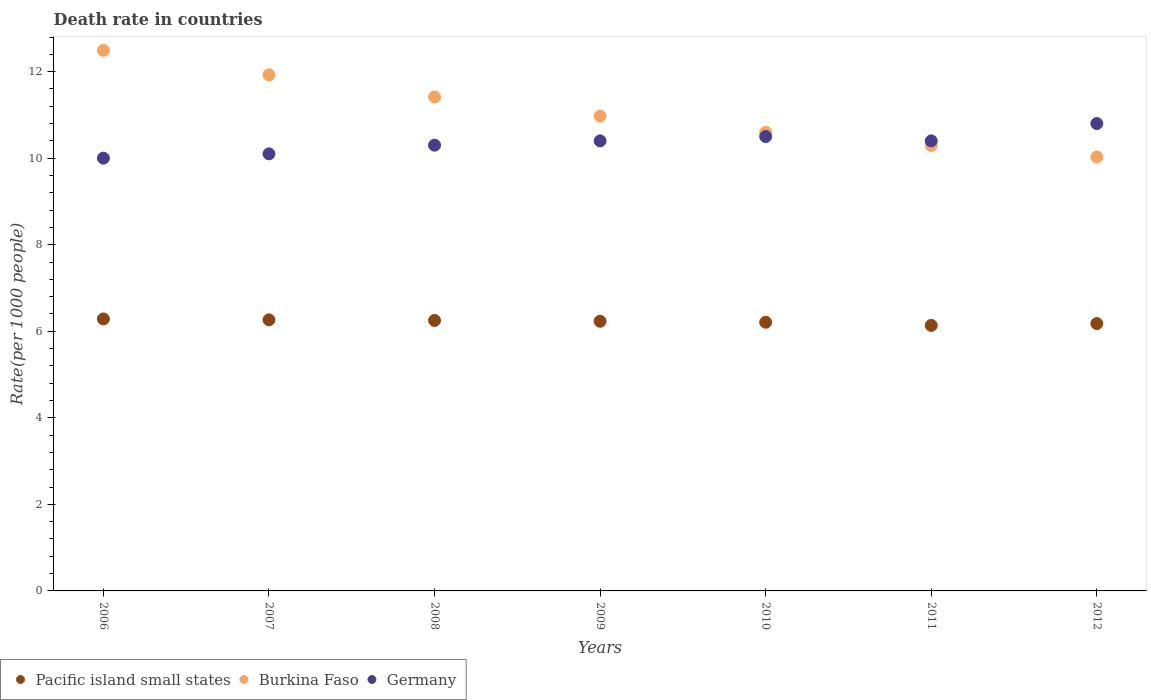What is the death rate in Pacific island small states in 2011?
Make the answer very short. 6.14. Across all years, what is the maximum death rate in Burkina Faso?
Offer a very short reply. 12.49. Across all years, what is the minimum death rate in Burkina Faso?
Give a very brief answer. 10.03. In which year was the death rate in Burkina Faso minimum?
Offer a very short reply. 2012. What is the total death rate in Germany in the graph?
Ensure brevity in your answer.  72.5. What is the difference between the death rate in Germany in 2006 and that in 2011?
Your answer should be very brief. -0.4. What is the difference between the death rate in Burkina Faso in 2006 and the death rate in Germany in 2007?
Provide a short and direct response. 2.39. What is the average death rate in Germany per year?
Ensure brevity in your answer.  10.36. In the year 2008, what is the difference between the death rate in Germany and death rate in Pacific island small states?
Provide a short and direct response. 4.05. What is the ratio of the death rate in Pacific island small states in 2010 to that in 2012?
Offer a very short reply. 1. What is the difference between the highest and the second highest death rate in Burkina Faso?
Provide a short and direct response. 0.57. What is the difference between the highest and the lowest death rate in Burkina Faso?
Your answer should be very brief. 2.46. Is the sum of the death rate in Pacific island small states in 2008 and 2009 greater than the maximum death rate in Burkina Faso across all years?
Keep it short and to the point. No. Is it the case that in every year, the sum of the death rate in Pacific island small states and death rate in Burkina Faso  is greater than the death rate in Germany?
Your answer should be very brief. Yes. Is the death rate in Burkina Faso strictly less than the death rate in Germany over the years?
Make the answer very short. No. Are the values on the major ticks of Y-axis written in scientific E-notation?
Give a very brief answer. No. Does the graph contain any zero values?
Give a very brief answer. No. How many legend labels are there?
Keep it short and to the point. 3. How are the legend labels stacked?
Your answer should be compact. Horizontal. What is the title of the graph?
Make the answer very short. Death rate in countries. Does "Saudi Arabia" appear as one of the legend labels in the graph?
Your answer should be very brief. No. What is the label or title of the Y-axis?
Offer a terse response. Rate(per 1000 people). What is the Rate(per 1000 people) in Pacific island small states in 2006?
Provide a short and direct response. 6.28. What is the Rate(per 1000 people) of Burkina Faso in 2006?
Your answer should be compact. 12.49. What is the Rate(per 1000 people) of Germany in 2006?
Offer a very short reply. 10. What is the Rate(per 1000 people) of Pacific island small states in 2007?
Keep it short and to the point. 6.26. What is the Rate(per 1000 people) in Burkina Faso in 2007?
Offer a very short reply. 11.93. What is the Rate(per 1000 people) of Germany in 2007?
Offer a very short reply. 10.1. What is the Rate(per 1000 people) of Pacific island small states in 2008?
Your answer should be very brief. 6.25. What is the Rate(per 1000 people) of Burkina Faso in 2008?
Keep it short and to the point. 11.41. What is the Rate(per 1000 people) in Germany in 2008?
Ensure brevity in your answer.  10.3. What is the Rate(per 1000 people) of Pacific island small states in 2009?
Your answer should be very brief. 6.23. What is the Rate(per 1000 people) in Burkina Faso in 2009?
Keep it short and to the point. 10.97. What is the Rate(per 1000 people) of Germany in 2009?
Provide a short and direct response. 10.4. What is the Rate(per 1000 people) in Pacific island small states in 2010?
Your answer should be compact. 6.21. What is the Rate(per 1000 people) in Germany in 2010?
Your answer should be compact. 10.5. What is the Rate(per 1000 people) of Pacific island small states in 2011?
Offer a terse response. 6.14. What is the Rate(per 1000 people) in Burkina Faso in 2011?
Your answer should be very brief. 10.29. What is the Rate(per 1000 people) in Pacific island small states in 2012?
Your answer should be very brief. 6.18. What is the Rate(per 1000 people) of Burkina Faso in 2012?
Your answer should be very brief. 10.03. What is the Rate(per 1000 people) of Germany in 2012?
Ensure brevity in your answer.  10.8. Across all years, what is the maximum Rate(per 1000 people) in Pacific island small states?
Give a very brief answer. 6.28. Across all years, what is the maximum Rate(per 1000 people) in Burkina Faso?
Your answer should be very brief. 12.49. Across all years, what is the maximum Rate(per 1000 people) of Germany?
Your answer should be very brief. 10.8. Across all years, what is the minimum Rate(per 1000 people) of Pacific island small states?
Make the answer very short. 6.14. Across all years, what is the minimum Rate(per 1000 people) in Burkina Faso?
Give a very brief answer. 10.03. What is the total Rate(per 1000 people) in Pacific island small states in the graph?
Offer a very short reply. 43.55. What is the total Rate(per 1000 people) of Burkina Faso in the graph?
Ensure brevity in your answer.  77.72. What is the total Rate(per 1000 people) of Germany in the graph?
Keep it short and to the point. 72.5. What is the difference between the Rate(per 1000 people) of Pacific island small states in 2006 and that in 2007?
Provide a short and direct response. 0.02. What is the difference between the Rate(per 1000 people) in Burkina Faso in 2006 and that in 2007?
Offer a very short reply. 0.57. What is the difference between the Rate(per 1000 people) of Germany in 2006 and that in 2007?
Offer a very short reply. -0.1. What is the difference between the Rate(per 1000 people) of Pacific island small states in 2006 and that in 2008?
Ensure brevity in your answer.  0.03. What is the difference between the Rate(per 1000 people) in Burkina Faso in 2006 and that in 2008?
Offer a terse response. 1.08. What is the difference between the Rate(per 1000 people) of Pacific island small states in 2006 and that in 2009?
Your answer should be very brief. 0.05. What is the difference between the Rate(per 1000 people) of Burkina Faso in 2006 and that in 2009?
Offer a terse response. 1.52. What is the difference between the Rate(per 1000 people) in Pacific island small states in 2006 and that in 2010?
Offer a terse response. 0.08. What is the difference between the Rate(per 1000 people) in Burkina Faso in 2006 and that in 2010?
Offer a terse response. 1.89. What is the difference between the Rate(per 1000 people) of Pacific island small states in 2006 and that in 2011?
Your answer should be very brief. 0.15. What is the difference between the Rate(per 1000 people) of Burkina Faso in 2006 and that in 2011?
Give a very brief answer. 2.2. What is the difference between the Rate(per 1000 people) in Germany in 2006 and that in 2011?
Provide a short and direct response. -0.4. What is the difference between the Rate(per 1000 people) of Pacific island small states in 2006 and that in 2012?
Ensure brevity in your answer.  0.11. What is the difference between the Rate(per 1000 people) of Burkina Faso in 2006 and that in 2012?
Make the answer very short. 2.46. What is the difference between the Rate(per 1000 people) in Pacific island small states in 2007 and that in 2008?
Provide a succinct answer. 0.01. What is the difference between the Rate(per 1000 people) of Burkina Faso in 2007 and that in 2008?
Your answer should be compact. 0.51. What is the difference between the Rate(per 1000 people) in Pacific island small states in 2007 and that in 2009?
Your answer should be very brief. 0.03. What is the difference between the Rate(per 1000 people) of Burkina Faso in 2007 and that in 2009?
Offer a very short reply. 0.95. What is the difference between the Rate(per 1000 people) in Germany in 2007 and that in 2009?
Give a very brief answer. -0.3. What is the difference between the Rate(per 1000 people) of Pacific island small states in 2007 and that in 2010?
Make the answer very short. 0.06. What is the difference between the Rate(per 1000 people) in Burkina Faso in 2007 and that in 2010?
Offer a terse response. 1.33. What is the difference between the Rate(per 1000 people) of Germany in 2007 and that in 2010?
Offer a terse response. -0.4. What is the difference between the Rate(per 1000 people) in Pacific island small states in 2007 and that in 2011?
Ensure brevity in your answer.  0.13. What is the difference between the Rate(per 1000 people) in Burkina Faso in 2007 and that in 2011?
Your answer should be compact. 1.63. What is the difference between the Rate(per 1000 people) in Pacific island small states in 2007 and that in 2012?
Offer a terse response. 0.09. What is the difference between the Rate(per 1000 people) in Burkina Faso in 2007 and that in 2012?
Give a very brief answer. 1.9. What is the difference between the Rate(per 1000 people) of Pacific island small states in 2008 and that in 2009?
Make the answer very short. 0.02. What is the difference between the Rate(per 1000 people) in Burkina Faso in 2008 and that in 2009?
Offer a very short reply. 0.44. What is the difference between the Rate(per 1000 people) of Pacific island small states in 2008 and that in 2010?
Make the answer very short. 0.04. What is the difference between the Rate(per 1000 people) of Burkina Faso in 2008 and that in 2010?
Keep it short and to the point. 0.81. What is the difference between the Rate(per 1000 people) of Pacific island small states in 2008 and that in 2011?
Your answer should be very brief. 0.11. What is the difference between the Rate(per 1000 people) in Burkina Faso in 2008 and that in 2011?
Provide a succinct answer. 1.12. What is the difference between the Rate(per 1000 people) in Germany in 2008 and that in 2011?
Your response must be concise. -0.1. What is the difference between the Rate(per 1000 people) in Pacific island small states in 2008 and that in 2012?
Provide a short and direct response. 0.07. What is the difference between the Rate(per 1000 people) of Burkina Faso in 2008 and that in 2012?
Offer a very short reply. 1.39. What is the difference between the Rate(per 1000 people) of Germany in 2008 and that in 2012?
Your answer should be compact. -0.5. What is the difference between the Rate(per 1000 people) in Pacific island small states in 2009 and that in 2010?
Ensure brevity in your answer.  0.02. What is the difference between the Rate(per 1000 people) in Burkina Faso in 2009 and that in 2010?
Your answer should be compact. 0.37. What is the difference between the Rate(per 1000 people) in Pacific island small states in 2009 and that in 2011?
Make the answer very short. 0.1. What is the difference between the Rate(per 1000 people) of Burkina Faso in 2009 and that in 2011?
Your response must be concise. 0.68. What is the difference between the Rate(per 1000 people) of Pacific island small states in 2009 and that in 2012?
Your answer should be very brief. 0.05. What is the difference between the Rate(per 1000 people) in Burkina Faso in 2009 and that in 2012?
Offer a very short reply. 0.94. What is the difference between the Rate(per 1000 people) of Germany in 2009 and that in 2012?
Provide a succinct answer. -0.4. What is the difference between the Rate(per 1000 people) of Pacific island small states in 2010 and that in 2011?
Your answer should be very brief. 0.07. What is the difference between the Rate(per 1000 people) in Burkina Faso in 2010 and that in 2011?
Your answer should be compact. 0.31. What is the difference between the Rate(per 1000 people) in Germany in 2010 and that in 2011?
Keep it short and to the point. 0.1. What is the difference between the Rate(per 1000 people) of Pacific island small states in 2010 and that in 2012?
Provide a short and direct response. 0.03. What is the difference between the Rate(per 1000 people) of Burkina Faso in 2010 and that in 2012?
Keep it short and to the point. 0.57. What is the difference between the Rate(per 1000 people) of Germany in 2010 and that in 2012?
Keep it short and to the point. -0.3. What is the difference between the Rate(per 1000 people) in Pacific island small states in 2011 and that in 2012?
Your answer should be very brief. -0.04. What is the difference between the Rate(per 1000 people) in Burkina Faso in 2011 and that in 2012?
Keep it short and to the point. 0.26. What is the difference between the Rate(per 1000 people) in Pacific island small states in 2006 and the Rate(per 1000 people) in Burkina Faso in 2007?
Offer a terse response. -5.64. What is the difference between the Rate(per 1000 people) of Pacific island small states in 2006 and the Rate(per 1000 people) of Germany in 2007?
Your answer should be very brief. -3.82. What is the difference between the Rate(per 1000 people) of Burkina Faso in 2006 and the Rate(per 1000 people) of Germany in 2007?
Make the answer very short. 2.39. What is the difference between the Rate(per 1000 people) of Pacific island small states in 2006 and the Rate(per 1000 people) of Burkina Faso in 2008?
Your answer should be compact. -5.13. What is the difference between the Rate(per 1000 people) in Pacific island small states in 2006 and the Rate(per 1000 people) in Germany in 2008?
Keep it short and to the point. -4.02. What is the difference between the Rate(per 1000 people) in Burkina Faso in 2006 and the Rate(per 1000 people) in Germany in 2008?
Your answer should be very brief. 2.19. What is the difference between the Rate(per 1000 people) in Pacific island small states in 2006 and the Rate(per 1000 people) in Burkina Faso in 2009?
Keep it short and to the point. -4.69. What is the difference between the Rate(per 1000 people) in Pacific island small states in 2006 and the Rate(per 1000 people) in Germany in 2009?
Provide a succinct answer. -4.12. What is the difference between the Rate(per 1000 people) of Burkina Faso in 2006 and the Rate(per 1000 people) of Germany in 2009?
Keep it short and to the point. 2.09. What is the difference between the Rate(per 1000 people) of Pacific island small states in 2006 and the Rate(per 1000 people) of Burkina Faso in 2010?
Make the answer very short. -4.32. What is the difference between the Rate(per 1000 people) in Pacific island small states in 2006 and the Rate(per 1000 people) in Germany in 2010?
Give a very brief answer. -4.22. What is the difference between the Rate(per 1000 people) of Burkina Faso in 2006 and the Rate(per 1000 people) of Germany in 2010?
Make the answer very short. 1.99. What is the difference between the Rate(per 1000 people) in Pacific island small states in 2006 and the Rate(per 1000 people) in Burkina Faso in 2011?
Give a very brief answer. -4.01. What is the difference between the Rate(per 1000 people) of Pacific island small states in 2006 and the Rate(per 1000 people) of Germany in 2011?
Offer a very short reply. -4.12. What is the difference between the Rate(per 1000 people) in Burkina Faso in 2006 and the Rate(per 1000 people) in Germany in 2011?
Offer a very short reply. 2.09. What is the difference between the Rate(per 1000 people) in Pacific island small states in 2006 and the Rate(per 1000 people) in Burkina Faso in 2012?
Your response must be concise. -3.74. What is the difference between the Rate(per 1000 people) of Pacific island small states in 2006 and the Rate(per 1000 people) of Germany in 2012?
Provide a succinct answer. -4.52. What is the difference between the Rate(per 1000 people) of Burkina Faso in 2006 and the Rate(per 1000 people) of Germany in 2012?
Give a very brief answer. 1.69. What is the difference between the Rate(per 1000 people) of Pacific island small states in 2007 and the Rate(per 1000 people) of Burkina Faso in 2008?
Give a very brief answer. -5.15. What is the difference between the Rate(per 1000 people) in Pacific island small states in 2007 and the Rate(per 1000 people) in Germany in 2008?
Keep it short and to the point. -4.04. What is the difference between the Rate(per 1000 people) of Burkina Faso in 2007 and the Rate(per 1000 people) of Germany in 2008?
Ensure brevity in your answer.  1.63. What is the difference between the Rate(per 1000 people) of Pacific island small states in 2007 and the Rate(per 1000 people) of Burkina Faso in 2009?
Your response must be concise. -4.71. What is the difference between the Rate(per 1000 people) in Pacific island small states in 2007 and the Rate(per 1000 people) in Germany in 2009?
Your response must be concise. -4.14. What is the difference between the Rate(per 1000 people) of Burkina Faso in 2007 and the Rate(per 1000 people) of Germany in 2009?
Provide a succinct answer. 1.53. What is the difference between the Rate(per 1000 people) in Pacific island small states in 2007 and the Rate(per 1000 people) in Burkina Faso in 2010?
Offer a terse response. -4.34. What is the difference between the Rate(per 1000 people) in Pacific island small states in 2007 and the Rate(per 1000 people) in Germany in 2010?
Offer a terse response. -4.24. What is the difference between the Rate(per 1000 people) in Burkina Faso in 2007 and the Rate(per 1000 people) in Germany in 2010?
Make the answer very short. 1.43. What is the difference between the Rate(per 1000 people) of Pacific island small states in 2007 and the Rate(per 1000 people) of Burkina Faso in 2011?
Ensure brevity in your answer.  -4.03. What is the difference between the Rate(per 1000 people) in Pacific island small states in 2007 and the Rate(per 1000 people) in Germany in 2011?
Give a very brief answer. -4.14. What is the difference between the Rate(per 1000 people) of Burkina Faso in 2007 and the Rate(per 1000 people) of Germany in 2011?
Your answer should be very brief. 1.53. What is the difference between the Rate(per 1000 people) in Pacific island small states in 2007 and the Rate(per 1000 people) in Burkina Faso in 2012?
Make the answer very short. -3.76. What is the difference between the Rate(per 1000 people) of Pacific island small states in 2007 and the Rate(per 1000 people) of Germany in 2012?
Ensure brevity in your answer.  -4.54. What is the difference between the Rate(per 1000 people) of Burkina Faso in 2007 and the Rate(per 1000 people) of Germany in 2012?
Keep it short and to the point. 1.13. What is the difference between the Rate(per 1000 people) of Pacific island small states in 2008 and the Rate(per 1000 people) of Burkina Faso in 2009?
Provide a short and direct response. -4.72. What is the difference between the Rate(per 1000 people) of Pacific island small states in 2008 and the Rate(per 1000 people) of Germany in 2009?
Provide a succinct answer. -4.15. What is the difference between the Rate(per 1000 people) in Pacific island small states in 2008 and the Rate(per 1000 people) in Burkina Faso in 2010?
Keep it short and to the point. -4.35. What is the difference between the Rate(per 1000 people) in Pacific island small states in 2008 and the Rate(per 1000 people) in Germany in 2010?
Offer a very short reply. -4.25. What is the difference between the Rate(per 1000 people) of Burkina Faso in 2008 and the Rate(per 1000 people) of Germany in 2010?
Provide a succinct answer. 0.92. What is the difference between the Rate(per 1000 people) in Pacific island small states in 2008 and the Rate(per 1000 people) in Burkina Faso in 2011?
Keep it short and to the point. -4.04. What is the difference between the Rate(per 1000 people) in Pacific island small states in 2008 and the Rate(per 1000 people) in Germany in 2011?
Your answer should be compact. -4.15. What is the difference between the Rate(per 1000 people) in Burkina Faso in 2008 and the Rate(per 1000 people) in Germany in 2011?
Your response must be concise. 1.01. What is the difference between the Rate(per 1000 people) in Pacific island small states in 2008 and the Rate(per 1000 people) in Burkina Faso in 2012?
Your response must be concise. -3.78. What is the difference between the Rate(per 1000 people) in Pacific island small states in 2008 and the Rate(per 1000 people) in Germany in 2012?
Give a very brief answer. -4.55. What is the difference between the Rate(per 1000 people) of Burkina Faso in 2008 and the Rate(per 1000 people) of Germany in 2012?
Ensure brevity in your answer.  0.61. What is the difference between the Rate(per 1000 people) in Pacific island small states in 2009 and the Rate(per 1000 people) in Burkina Faso in 2010?
Make the answer very short. -4.37. What is the difference between the Rate(per 1000 people) in Pacific island small states in 2009 and the Rate(per 1000 people) in Germany in 2010?
Offer a very short reply. -4.27. What is the difference between the Rate(per 1000 people) of Burkina Faso in 2009 and the Rate(per 1000 people) of Germany in 2010?
Ensure brevity in your answer.  0.47. What is the difference between the Rate(per 1000 people) of Pacific island small states in 2009 and the Rate(per 1000 people) of Burkina Faso in 2011?
Ensure brevity in your answer.  -4.06. What is the difference between the Rate(per 1000 people) of Pacific island small states in 2009 and the Rate(per 1000 people) of Germany in 2011?
Give a very brief answer. -4.17. What is the difference between the Rate(per 1000 people) in Burkina Faso in 2009 and the Rate(per 1000 people) in Germany in 2011?
Give a very brief answer. 0.57. What is the difference between the Rate(per 1000 people) in Pacific island small states in 2009 and the Rate(per 1000 people) in Burkina Faso in 2012?
Provide a short and direct response. -3.8. What is the difference between the Rate(per 1000 people) of Pacific island small states in 2009 and the Rate(per 1000 people) of Germany in 2012?
Offer a terse response. -4.57. What is the difference between the Rate(per 1000 people) in Burkina Faso in 2009 and the Rate(per 1000 people) in Germany in 2012?
Your answer should be very brief. 0.17. What is the difference between the Rate(per 1000 people) of Pacific island small states in 2010 and the Rate(per 1000 people) of Burkina Faso in 2011?
Your answer should be very brief. -4.08. What is the difference between the Rate(per 1000 people) of Pacific island small states in 2010 and the Rate(per 1000 people) of Germany in 2011?
Give a very brief answer. -4.19. What is the difference between the Rate(per 1000 people) in Burkina Faso in 2010 and the Rate(per 1000 people) in Germany in 2011?
Your answer should be very brief. 0.2. What is the difference between the Rate(per 1000 people) in Pacific island small states in 2010 and the Rate(per 1000 people) in Burkina Faso in 2012?
Provide a short and direct response. -3.82. What is the difference between the Rate(per 1000 people) in Pacific island small states in 2010 and the Rate(per 1000 people) in Germany in 2012?
Offer a very short reply. -4.59. What is the difference between the Rate(per 1000 people) of Burkina Faso in 2010 and the Rate(per 1000 people) of Germany in 2012?
Provide a short and direct response. -0.2. What is the difference between the Rate(per 1000 people) of Pacific island small states in 2011 and the Rate(per 1000 people) of Burkina Faso in 2012?
Your answer should be compact. -3.89. What is the difference between the Rate(per 1000 people) of Pacific island small states in 2011 and the Rate(per 1000 people) of Germany in 2012?
Your response must be concise. -4.66. What is the difference between the Rate(per 1000 people) in Burkina Faso in 2011 and the Rate(per 1000 people) in Germany in 2012?
Ensure brevity in your answer.  -0.51. What is the average Rate(per 1000 people) in Pacific island small states per year?
Provide a succinct answer. 6.22. What is the average Rate(per 1000 people) in Burkina Faso per year?
Your answer should be compact. 11.1. What is the average Rate(per 1000 people) of Germany per year?
Keep it short and to the point. 10.36. In the year 2006, what is the difference between the Rate(per 1000 people) in Pacific island small states and Rate(per 1000 people) in Burkina Faso?
Your answer should be compact. -6.21. In the year 2006, what is the difference between the Rate(per 1000 people) of Pacific island small states and Rate(per 1000 people) of Germany?
Your answer should be very brief. -3.72. In the year 2006, what is the difference between the Rate(per 1000 people) in Burkina Faso and Rate(per 1000 people) in Germany?
Provide a succinct answer. 2.49. In the year 2007, what is the difference between the Rate(per 1000 people) of Pacific island small states and Rate(per 1000 people) of Burkina Faso?
Your answer should be compact. -5.66. In the year 2007, what is the difference between the Rate(per 1000 people) of Pacific island small states and Rate(per 1000 people) of Germany?
Ensure brevity in your answer.  -3.84. In the year 2007, what is the difference between the Rate(per 1000 people) in Burkina Faso and Rate(per 1000 people) in Germany?
Keep it short and to the point. 1.83. In the year 2008, what is the difference between the Rate(per 1000 people) of Pacific island small states and Rate(per 1000 people) of Burkina Faso?
Offer a terse response. -5.17. In the year 2008, what is the difference between the Rate(per 1000 people) of Pacific island small states and Rate(per 1000 people) of Germany?
Give a very brief answer. -4.05. In the year 2008, what is the difference between the Rate(per 1000 people) in Burkina Faso and Rate(per 1000 people) in Germany?
Give a very brief answer. 1.11. In the year 2009, what is the difference between the Rate(per 1000 people) of Pacific island small states and Rate(per 1000 people) of Burkina Faso?
Offer a terse response. -4.74. In the year 2009, what is the difference between the Rate(per 1000 people) in Pacific island small states and Rate(per 1000 people) in Germany?
Your answer should be compact. -4.17. In the year 2009, what is the difference between the Rate(per 1000 people) in Burkina Faso and Rate(per 1000 people) in Germany?
Provide a short and direct response. 0.57. In the year 2010, what is the difference between the Rate(per 1000 people) in Pacific island small states and Rate(per 1000 people) in Burkina Faso?
Make the answer very short. -4.39. In the year 2010, what is the difference between the Rate(per 1000 people) of Pacific island small states and Rate(per 1000 people) of Germany?
Your answer should be compact. -4.29. In the year 2010, what is the difference between the Rate(per 1000 people) in Burkina Faso and Rate(per 1000 people) in Germany?
Give a very brief answer. 0.1. In the year 2011, what is the difference between the Rate(per 1000 people) of Pacific island small states and Rate(per 1000 people) of Burkina Faso?
Give a very brief answer. -4.16. In the year 2011, what is the difference between the Rate(per 1000 people) in Pacific island small states and Rate(per 1000 people) in Germany?
Offer a very short reply. -4.26. In the year 2011, what is the difference between the Rate(per 1000 people) of Burkina Faso and Rate(per 1000 people) of Germany?
Offer a terse response. -0.11. In the year 2012, what is the difference between the Rate(per 1000 people) in Pacific island small states and Rate(per 1000 people) in Burkina Faso?
Your response must be concise. -3.85. In the year 2012, what is the difference between the Rate(per 1000 people) of Pacific island small states and Rate(per 1000 people) of Germany?
Make the answer very short. -4.62. In the year 2012, what is the difference between the Rate(per 1000 people) in Burkina Faso and Rate(per 1000 people) in Germany?
Your answer should be compact. -0.77. What is the ratio of the Rate(per 1000 people) of Pacific island small states in 2006 to that in 2007?
Your answer should be compact. 1. What is the ratio of the Rate(per 1000 people) of Burkina Faso in 2006 to that in 2007?
Your answer should be compact. 1.05. What is the ratio of the Rate(per 1000 people) of Pacific island small states in 2006 to that in 2008?
Your answer should be compact. 1.01. What is the ratio of the Rate(per 1000 people) in Burkina Faso in 2006 to that in 2008?
Give a very brief answer. 1.09. What is the ratio of the Rate(per 1000 people) of Germany in 2006 to that in 2008?
Offer a very short reply. 0.97. What is the ratio of the Rate(per 1000 people) of Pacific island small states in 2006 to that in 2009?
Your response must be concise. 1.01. What is the ratio of the Rate(per 1000 people) in Burkina Faso in 2006 to that in 2009?
Ensure brevity in your answer.  1.14. What is the ratio of the Rate(per 1000 people) of Germany in 2006 to that in 2009?
Keep it short and to the point. 0.96. What is the ratio of the Rate(per 1000 people) of Pacific island small states in 2006 to that in 2010?
Provide a succinct answer. 1.01. What is the ratio of the Rate(per 1000 people) of Burkina Faso in 2006 to that in 2010?
Make the answer very short. 1.18. What is the ratio of the Rate(per 1000 people) in Germany in 2006 to that in 2010?
Your response must be concise. 0.95. What is the ratio of the Rate(per 1000 people) of Pacific island small states in 2006 to that in 2011?
Give a very brief answer. 1.02. What is the ratio of the Rate(per 1000 people) of Burkina Faso in 2006 to that in 2011?
Make the answer very short. 1.21. What is the ratio of the Rate(per 1000 people) in Germany in 2006 to that in 2011?
Offer a terse response. 0.96. What is the ratio of the Rate(per 1000 people) in Pacific island small states in 2006 to that in 2012?
Your answer should be very brief. 1.02. What is the ratio of the Rate(per 1000 people) of Burkina Faso in 2006 to that in 2012?
Give a very brief answer. 1.25. What is the ratio of the Rate(per 1000 people) of Germany in 2006 to that in 2012?
Your answer should be compact. 0.93. What is the ratio of the Rate(per 1000 people) of Burkina Faso in 2007 to that in 2008?
Provide a succinct answer. 1.04. What is the ratio of the Rate(per 1000 people) of Germany in 2007 to that in 2008?
Give a very brief answer. 0.98. What is the ratio of the Rate(per 1000 people) in Burkina Faso in 2007 to that in 2009?
Your response must be concise. 1.09. What is the ratio of the Rate(per 1000 people) in Germany in 2007 to that in 2009?
Make the answer very short. 0.97. What is the ratio of the Rate(per 1000 people) in Pacific island small states in 2007 to that in 2010?
Make the answer very short. 1.01. What is the ratio of the Rate(per 1000 people) of Burkina Faso in 2007 to that in 2010?
Your answer should be compact. 1.13. What is the ratio of the Rate(per 1000 people) in Germany in 2007 to that in 2010?
Your response must be concise. 0.96. What is the ratio of the Rate(per 1000 people) of Pacific island small states in 2007 to that in 2011?
Your response must be concise. 1.02. What is the ratio of the Rate(per 1000 people) of Burkina Faso in 2007 to that in 2011?
Offer a very short reply. 1.16. What is the ratio of the Rate(per 1000 people) of Germany in 2007 to that in 2011?
Offer a terse response. 0.97. What is the ratio of the Rate(per 1000 people) in Pacific island small states in 2007 to that in 2012?
Give a very brief answer. 1.01. What is the ratio of the Rate(per 1000 people) in Burkina Faso in 2007 to that in 2012?
Ensure brevity in your answer.  1.19. What is the ratio of the Rate(per 1000 people) of Germany in 2007 to that in 2012?
Provide a succinct answer. 0.94. What is the ratio of the Rate(per 1000 people) of Pacific island small states in 2008 to that in 2009?
Offer a very short reply. 1. What is the ratio of the Rate(per 1000 people) of Burkina Faso in 2008 to that in 2009?
Your answer should be compact. 1.04. What is the ratio of the Rate(per 1000 people) in Germany in 2008 to that in 2009?
Provide a succinct answer. 0.99. What is the ratio of the Rate(per 1000 people) in Pacific island small states in 2008 to that in 2011?
Provide a short and direct response. 1.02. What is the ratio of the Rate(per 1000 people) of Burkina Faso in 2008 to that in 2011?
Offer a terse response. 1.11. What is the ratio of the Rate(per 1000 people) in Germany in 2008 to that in 2011?
Your answer should be compact. 0.99. What is the ratio of the Rate(per 1000 people) in Pacific island small states in 2008 to that in 2012?
Keep it short and to the point. 1.01. What is the ratio of the Rate(per 1000 people) of Burkina Faso in 2008 to that in 2012?
Your answer should be compact. 1.14. What is the ratio of the Rate(per 1000 people) in Germany in 2008 to that in 2012?
Give a very brief answer. 0.95. What is the ratio of the Rate(per 1000 people) in Burkina Faso in 2009 to that in 2010?
Your answer should be compact. 1.04. What is the ratio of the Rate(per 1000 people) of Germany in 2009 to that in 2010?
Ensure brevity in your answer.  0.99. What is the ratio of the Rate(per 1000 people) of Pacific island small states in 2009 to that in 2011?
Offer a terse response. 1.02. What is the ratio of the Rate(per 1000 people) of Burkina Faso in 2009 to that in 2011?
Offer a terse response. 1.07. What is the ratio of the Rate(per 1000 people) of Pacific island small states in 2009 to that in 2012?
Give a very brief answer. 1.01. What is the ratio of the Rate(per 1000 people) in Burkina Faso in 2009 to that in 2012?
Ensure brevity in your answer.  1.09. What is the ratio of the Rate(per 1000 people) in Pacific island small states in 2010 to that in 2011?
Ensure brevity in your answer.  1.01. What is the ratio of the Rate(per 1000 people) in Burkina Faso in 2010 to that in 2011?
Provide a succinct answer. 1.03. What is the ratio of the Rate(per 1000 people) of Germany in 2010 to that in 2011?
Your answer should be very brief. 1.01. What is the ratio of the Rate(per 1000 people) in Pacific island small states in 2010 to that in 2012?
Your answer should be compact. 1. What is the ratio of the Rate(per 1000 people) of Burkina Faso in 2010 to that in 2012?
Provide a succinct answer. 1.06. What is the ratio of the Rate(per 1000 people) of Germany in 2010 to that in 2012?
Keep it short and to the point. 0.97. What is the ratio of the Rate(per 1000 people) in Burkina Faso in 2011 to that in 2012?
Offer a very short reply. 1.03. What is the ratio of the Rate(per 1000 people) of Germany in 2011 to that in 2012?
Provide a short and direct response. 0.96. What is the difference between the highest and the second highest Rate(per 1000 people) of Pacific island small states?
Keep it short and to the point. 0.02. What is the difference between the highest and the second highest Rate(per 1000 people) of Burkina Faso?
Offer a terse response. 0.57. What is the difference between the highest and the second highest Rate(per 1000 people) of Germany?
Offer a terse response. 0.3. What is the difference between the highest and the lowest Rate(per 1000 people) of Pacific island small states?
Offer a very short reply. 0.15. What is the difference between the highest and the lowest Rate(per 1000 people) of Burkina Faso?
Your response must be concise. 2.46. What is the difference between the highest and the lowest Rate(per 1000 people) in Germany?
Ensure brevity in your answer.  0.8. 